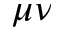<formula> <loc_0><loc_0><loc_500><loc_500>\mu \nu</formula> 